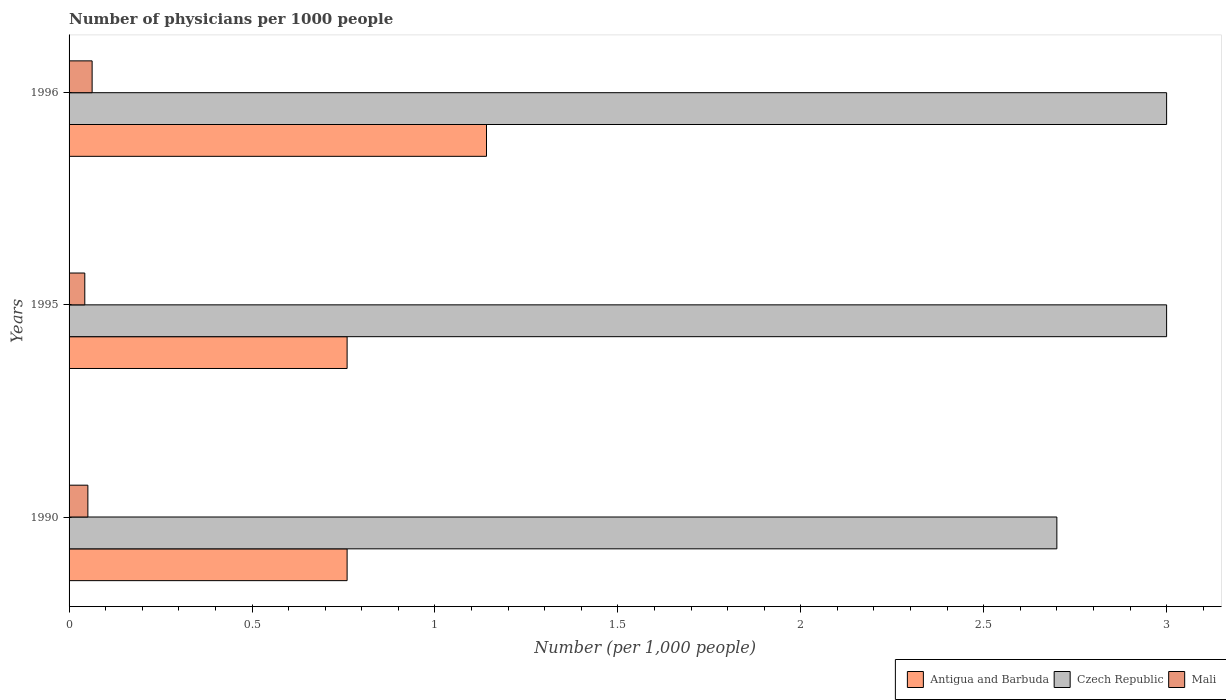How many groups of bars are there?
Give a very brief answer. 3. Are the number of bars per tick equal to the number of legend labels?
Offer a very short reply. Yes. In how many cases, is the number of bars for a given year not equal to the number of legend labels?
Provide a short and direct response. 0. What is the number of physicians in Antigua and Barbuda in 1995?
Offer a terse response. 0.76. Across all years, what is the maximum number of physicians in Mali?
Give a very brief answer. 0.06. Across all years, what is the minimum number of physicians in Mali?
Ensure brevity in your answer.  0.04. In which year was the number of physicians in Antigua and Barbuda maximum?
Your response must be concise. 1996. What is the total number of physicians in Mali in the graph?
Offer a very short reply. 0.16. What is the difference between the number of physicians in Mali in 1995 and that in 1996?
Make the answer very short. -0.02. What is the difference between the number of physicians in Mali in 1990 and the number of physicians in Antigua and Barbuda in 1996?
Give a very brief answer. -1.09. What is the average number of physicians in Mali per year?
Offer a very short reply. 0.05. In the year 1990, what is the difference between the number of physicians in Czech Republic and number of physicians in Antigua and Barbuda?
Make the answer very short. 1.94. What is the ratio of the number of physicians in Czech Republic in 1995 to that in 1996?
Provide a succinct answer. 1. What is the difference between the highest and the second highest number of physicians in Antigua and Barbuda?
Provide a short and direct response. 0.38. What is the difference between the highest and the lowest number of physicians in Antigua and Barbuda?
Offer a terse response. 0.38. In how many years, is the number of physicians in Mali greater than the average number of physicians in Mali taken over all years?
Make the answer very short. 1. What does the 3rd bar from the top in 1990 represents?
Provide a succinct answer. Antigua and Barbuda. What does the 2nd bar from the bottom in 1996 represents?
Keep it short and to the point. Czech Republic. How many bars are there?
Give a very brief answer. 9. How many years are there in the graph?
Keep it short and to the point. 3. What is the difference between two consecutive major ticks on the X-axis?
Your response must be concise. 0.5. Are the values on the major ticks of X-axis written in scientific E-notation?
Give a very brief answer. No. Does the graph contain any zero values?
Provide a succinct answer. No. What is the title of the graph?
Keep it short and to the point. Number of physicians per 1000 people. What is the label or title of the X-axis?
Keep it short and to the point. Number (per 1,0 people). What is the Number (per 1,000 people) in Antigua and Barbuda in 1990?
Give a very brief answer. 0.76. What is the Number (per 1,000 people) in Mali in 1990?
Give a very brief answer. 0.05. What is the Number (per 1,000 people) in Antigua and Barbuda in 1995?
Make the answer very short. 0.76. What is the Number (per 1,000 people) of Czech Republic in 1995?
Provide a short and direct response. 3. What is the Number (per 1,000 people) in Mali in 1995?
Your response must be concise. 0.04. What is the Number (per 1,000 people) in Antigua and Barbuda in 1996?
Your answer should be compact. 1.14. What is the Number (per 1,000 people) in Mali in 1996?
Offer a terse response. 0.06. Across all years, what is the maximum Number (per 1,000 people) of Antigua and Barbuda?
Ensure brevity in your answer.  1.14. Across all years, what is the maximum Number (per 1,000 people) in Czech Republic?
Offer a terse response. 3. Across all years, what is the maximum Number (per 1,000 people) of Mali?
Offer a very short reply. 0.06. Across all years, what is the minimum Number (per 1,000 people) of Antigua and Barbuda?
Your answer should be compact. 0.76. Across all years, what is the minimum Number (per 1,000 people) in Czech Republic?
Offer a very short reply. 2.7. Across all years, what is the minimum Number (per 1,000 people) in Mali?
Your answer should be very brief. 0.04. What is the total Number (per 1,000 people) in Antigua and Barbuda in the graph?
Your answer should be compact. 2.66. What is the total Number (per 1,000 people) of Czech Republic in the graph?
Provide a succinct answer. 8.7. What is the total Number (per 1,000 people) in Mali in the graph?
Your answer should be compact. 0.16. What is the difference between the Number (per 1,000 people) of Mali in 1990 and that in 1995?
Your response must be concise. 0.01. What is the difference between the Number (per 1,000 people) of Antigua and Barbuda in 1990 and that in 1996?
Ensure brevity in your answer.  -0.38. What is the difference between the Number (per 1,000 people) in Mali in 1990 and that in 1996?
Make the answer very short. -0.01. What is the difference between the Number (per 1,000 people) in Antigua and Barbuda in 1995 and that in 1996?
Give a very brief answer. -0.38. What is the difference between the Number (per 1,000 people) of Mali in 1995 and that in 1996?
Your answer should be compact. -0.02. What is the difference between the Number (per 1,000 people) in Antigua and Barbuda in 1990 and the Number (per 1,000 people) in Czech Republic in 1995?
Offer a terse response. -2.24. What is the difference between the Number (per 1,000 people) in Antigua and Barbuda in 1990 and the Number (per 1,000 people) in Mali in 1995?
Provide a short and direct response. 0.72. What is the difference between the Number (per 1,000 people) of Czech Republic in 1990 and the Number (per 1,000 people) of Mali in 1995?
Your response must be concise. 2.66. What is the difference between the Number (per 1,000 people) in Antigua and Barbuda in 1990 and the Number (per 1,000 people) in Czech Republic in 1996?
Offer a very short reply. -2.24. What is the difference between the Number (per 1,000 people) of Antigua and Barbuda in 1990 and the Number (per 1,000 people) of Mali in 1996?
Your response must be concise. 0.7. What is the difference between the Number (per 1,000 people) in Czech Republic in 1990 and the Number (per 1,000 people) in Mali in 1996?
Ensure brevity in your answer.  2.64. What is the difference between the Number (per 1,000 people) of Antigua and Barbuda in 1995 and the Number (per 1,000 people) of Czech Republic in 1996?
Provide a short and direct response. -2.24. What is the difference between the Number (per 1,000 people) in Antigua and Barbuda in 1995 and the Number (per 1,000 people) in Mali in 1996?
Your answer should be compact. 0.7. What is the difference between the Number (per 1,000 people) in Czech Republic in 1995 and the Number (per 1,000 people) in Mali in 1996?
Provide a succinct answer. 2.94. What is the average Number (per 1,000 people) of Antigua and Barbuda per year?
Offer a terse response. 0.89. What is the average Number (per 1,000 people) of Mali per year?
Offer a very short reply. 0.05. In the year 1990, what is the difference between the Number (per 1,000 people) in Antigua and Barbuda and Number (per 1,000 people) in Czech Republic?
Keep it short and to the point. -1.94. In the year 1990, what is the difference between the Number (per 1,000 people) of Antigua and Barbuda and Number (per 1,000 people) of Mali?
Offer a terse response. 0.71. In the year 1990, what is the difference between the Number (per 1,000 people) in Czech Republic and Number (per 1,000 people) in Mali?
Your answer should be compact. 2.65. In the year 1995, what is the difference between the Number (per 1,000 people) of Antigua and Barbuda and Number (per 1,000 people) of Czech Republic?
Your answer should be very brief. -2.24. In the year 1995, what is the difference between the Number (per 1,000 people) of Antigua and Barbuda and Number (per 1,000 people) of Mali?
Keep it short and to the point. 0.72. In the year 1995, what is the difference between the Number (per 1,000 people) of Czech Republic and Number (per 1,000 people) of Mali?
Provide a short and direct response. 2.96. In the year 1996, what is the difference between the Number (per 1,000 people) of Antigua and Barbuda and Number (per 1,000 people) of Czech Republic?
Offer a very short reply. -1.86. In the year 1996, what is the difference between the Number (per 1,000 people) of Antigua and Barbuda and Number (per 1,000 people) of Mali?
Offer a terse response. 1.08. In the year 1996, what is the difference between the Number (per 1,000 people) of Czech Republic and Number (per 1,000 people) of Mali?
Ensure brevity in your answer.  2.94. What is the ratio of the Number (per 1,000 people) in Antigua and Barbuda in 1990 to that in 1995?
Give a very brief answer. 1. What is the ratio of the Number (per 1,000 people) of Mali in 1990 to that in 1995?
Keep it short and to the point. 1.2. What is the ratio of the Number (per 1,000 people) in Antigua and Barbuda in 1990 to that in 1996?
Provide a succinct answer. 0.67. What is the ratio of the Number (per 1,000 people) in Mali in 1990 to that in 1996?
Your answer should be very brief. 0.82. What is the ratio of the Number (per 1,000 people) of Antigua and Barbuda in 1995 to that in 1996?
Offer a very short reply. 0.67. What is the ratio of the Number (per 1,000 people) in Mali in 1995 to that in 1996?
Give a very brief answer. 0.68. What is the difference between the highest and the second highest Number (per 1,000 people) of Antigua and Barbuda?
Provide a succinct answer. 0.38. What is the difference between the highest and the second highest Number (per 1,000 people) in Mali?
Keep it short and to the point. 0.01. What is the difference between the highest and the lowest Number (per 1,000 people) of Antigua and Barbuda?
Offer a terse response. 0.38. What is the difference between the highest and the lowest Number (per 1,000 people) in Mali?
Keep it short and to the point. 0.02. 